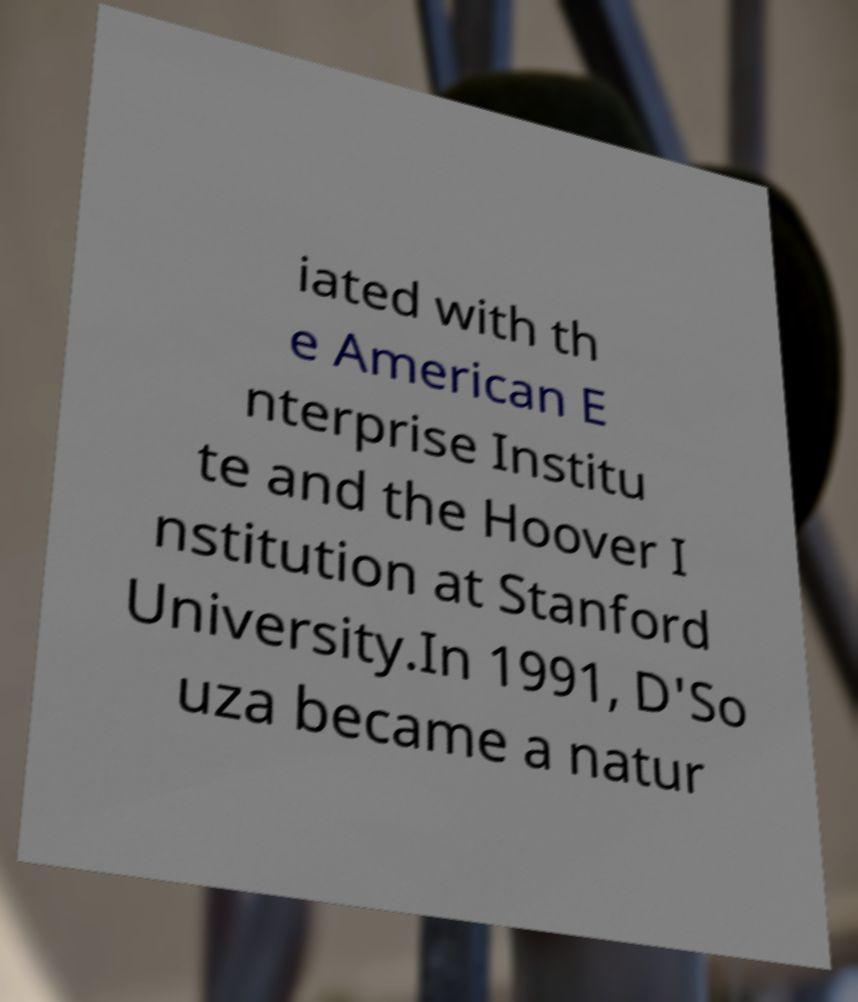Please read and relay the text visible in this image. What does it say? iated with th e American E nterprise Institu te and the Hoover I nstitution at Stanford University.In 1991, D'So uza became a natur 